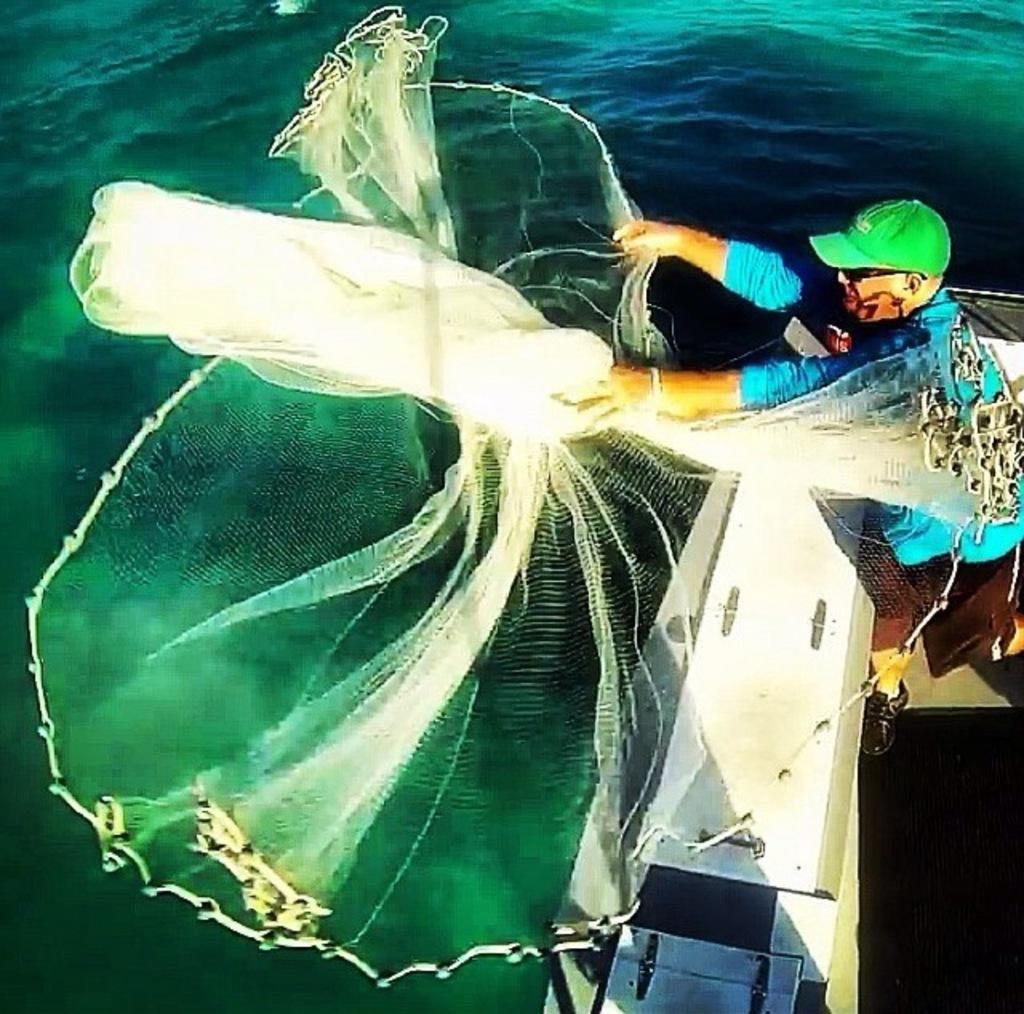What is the main subject of the image? The main subject of the image is a boat. Can you describe the person in the image? There is a man standing in the image. What object is present in the image that is typically used for fishing? There is a net in the image. What type of environment is visible in the image? There is water visible in the image. Where is the kitten playing with a pickle in the image? There is no kitten or pickle present in the image. What type of car can be seen driving through the water in the image? There is no car visible in the image; it features a boat and a man standing. 